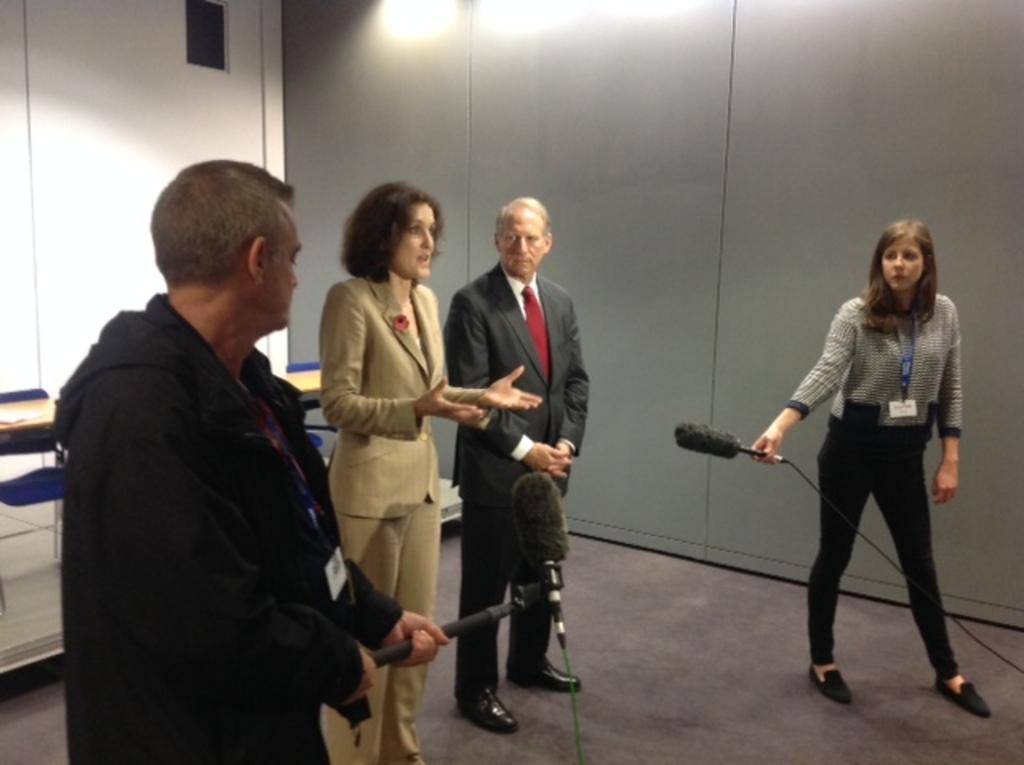Can you describe this image briefly? In this picture there are people in the center of the image and there is a lady and a man on the right and left side, by holding mics in their hands and there are lights at the top side of the image. 